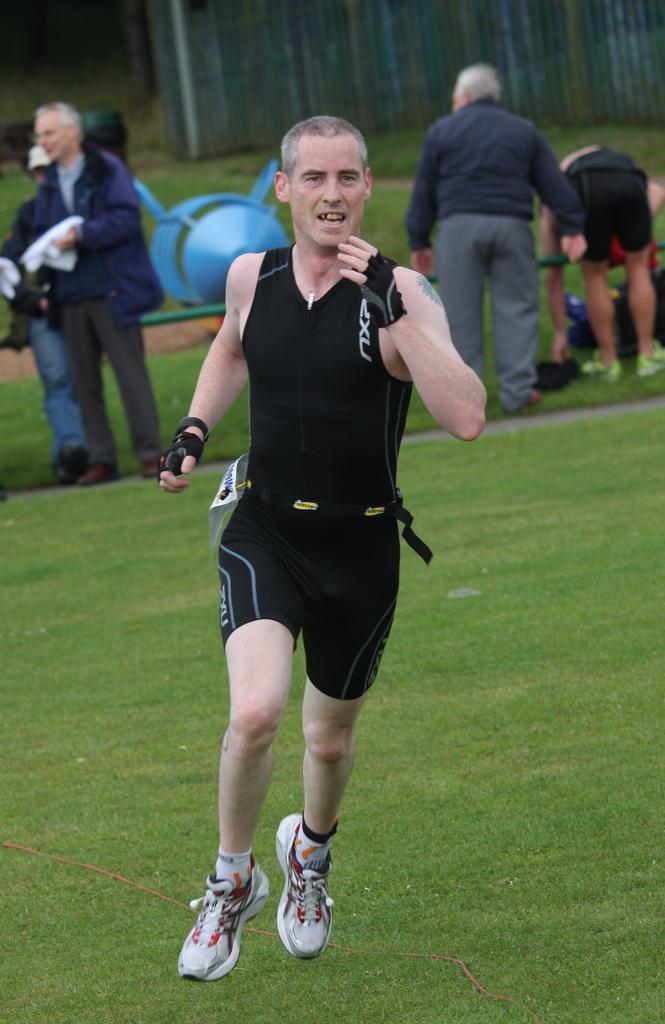Could you give a brief overview of what you see in this image? The man in front of the picture is running. At the bottom, we see the grass. Behind him, we see many people are standing. Beside them, we see an object in blue color. In the background, we see a pole and a wall which is made up of iron sheets. This picture is blurred in the background. 